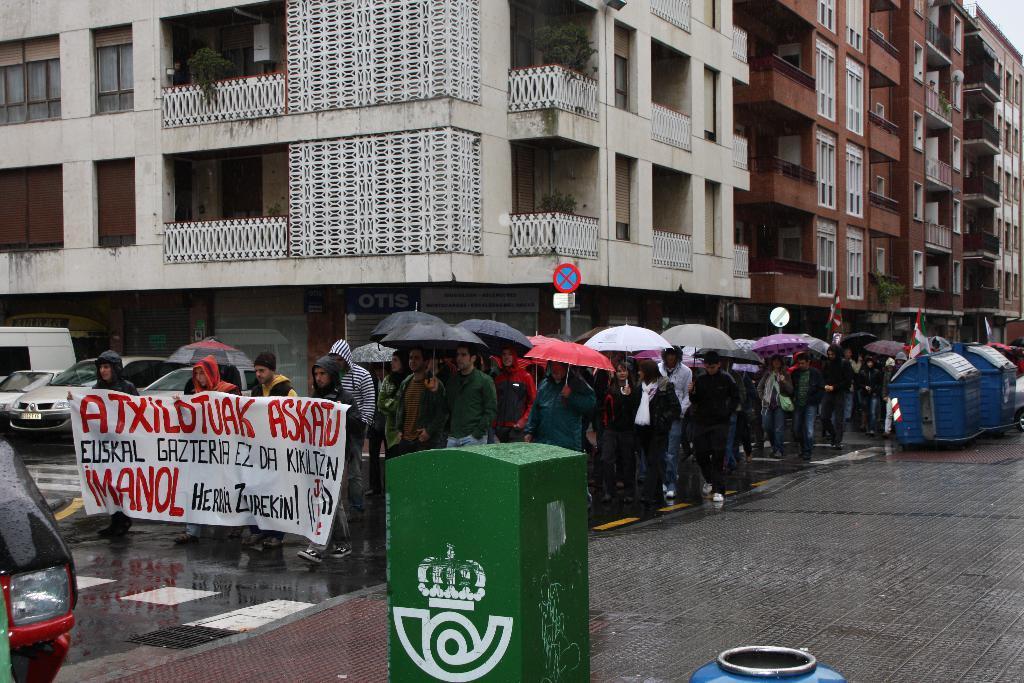In one or two sentences, can you explain what this image depicts? In this picture we can see some people holding a banner and some people holding the umbrellas. On the right side of the people there are plastic objects and on the left side of the people there are some vehicles parked on the road. Behind the people there are poles with the boards, buildings and flags. 